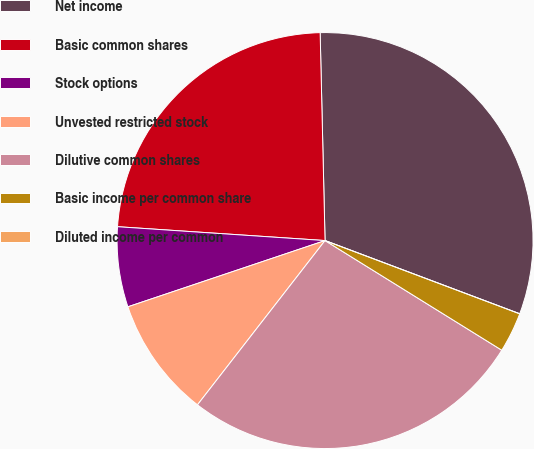Convert chart. <chart><loc_0><loc_0><loc_500><loc_500><pie_chart><fcel>Net income<fcel>Basic common shares<fcel>Stock options<fcel>Unvested restricted stock<fcel>Dilutive common shares<fcel>Basic income per common share<fcel>Diluted income per common<nl><fcel>31.1%<fcel>23.56%<fcel>6.22%<fcel>9.33%<fcel>26.67%<fcel>3.11%<fcel>0.0%<nl></chart> 